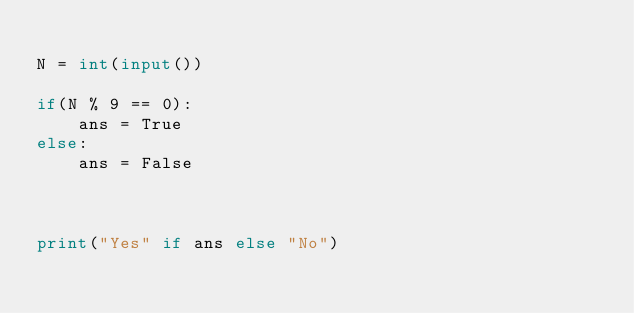<code> <loc_0><loc_0><loc_500><loc_500><_Python_>
N = int(input())

if(N % 9 == 0):
	ans = True
else:
	ans = False



print("Yes" if ans else "No")</code> 